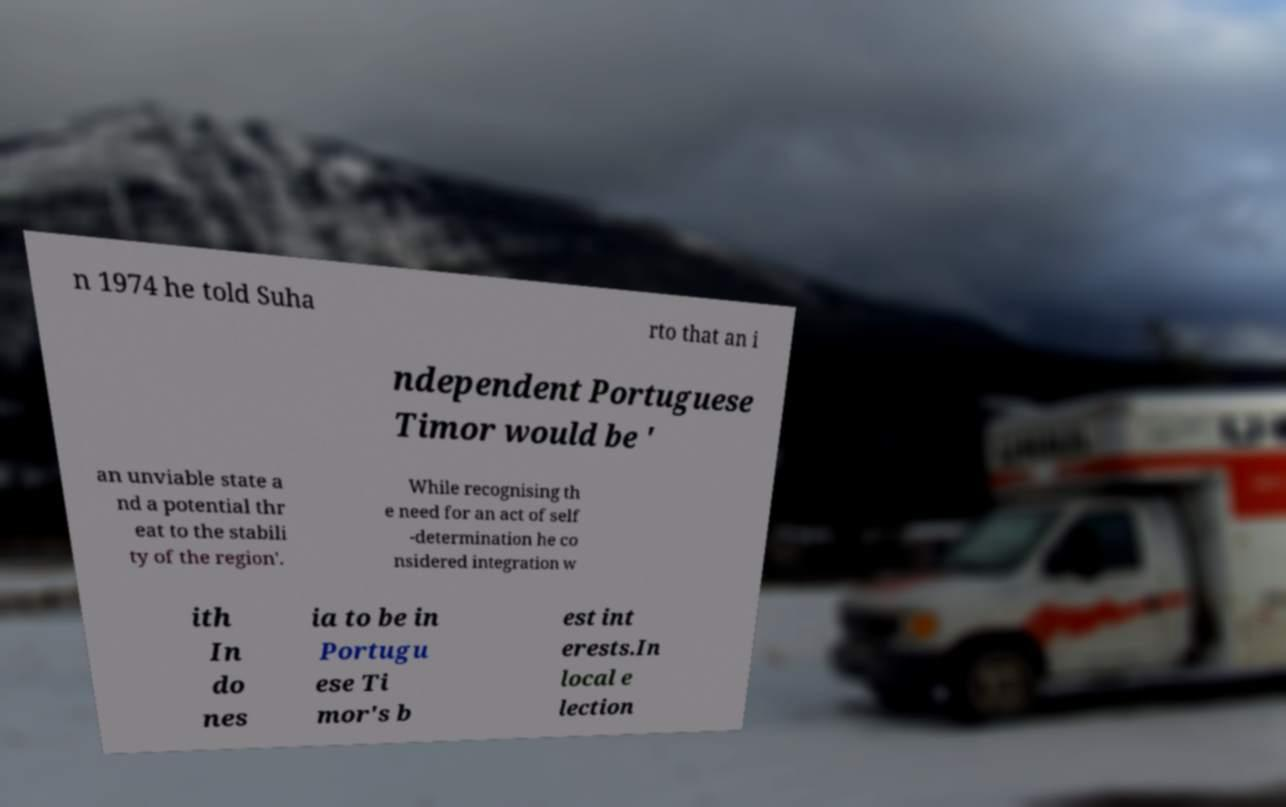What messages or text are displayed in this image? I need them in a readable, typed format. n 1974 he told Suha rto that an i ndependent Portuguese Timor would be ' an unviable state a nd a potential thr eat to the stabili ty of the region'. While recognising th e need for an act of self -determination he co nsidered integration w ith In do nes ia to be in Portugu ese Ti mor's b est int erests.In local e lection 